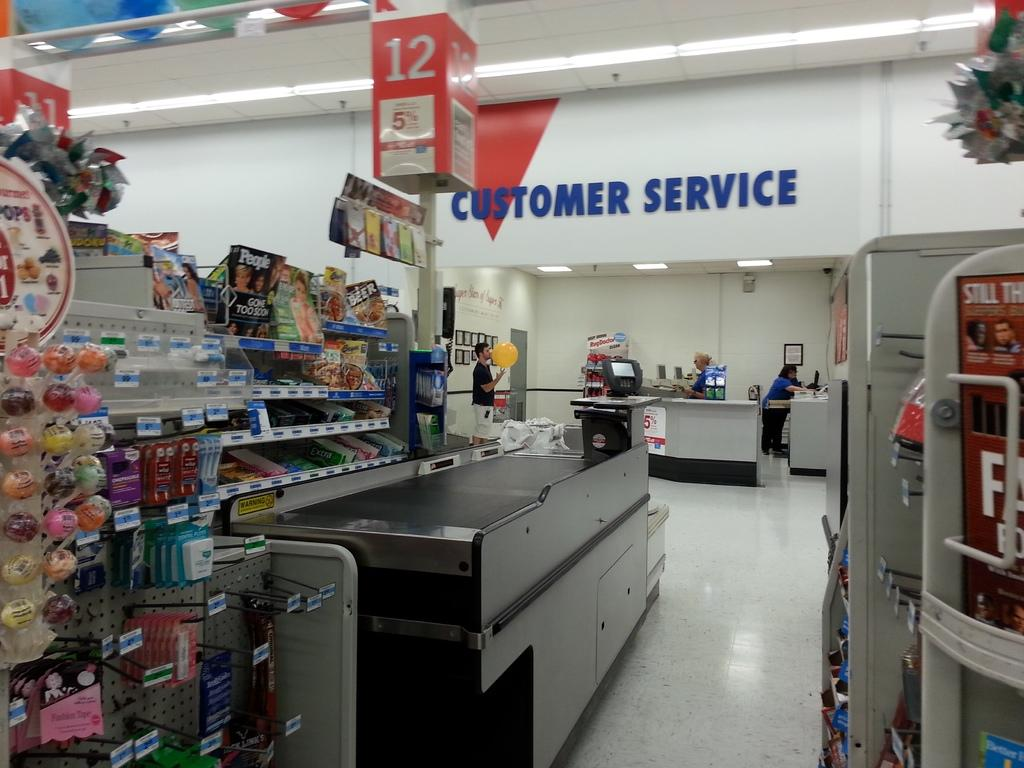Provide a one-sentence caption for the provided image. Customer service waits empty for customers to come need help. 